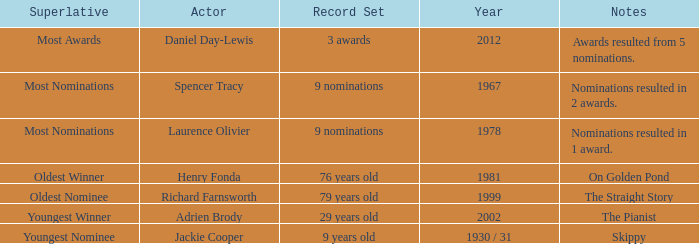In which year was the oldest winner? 1981.0. 